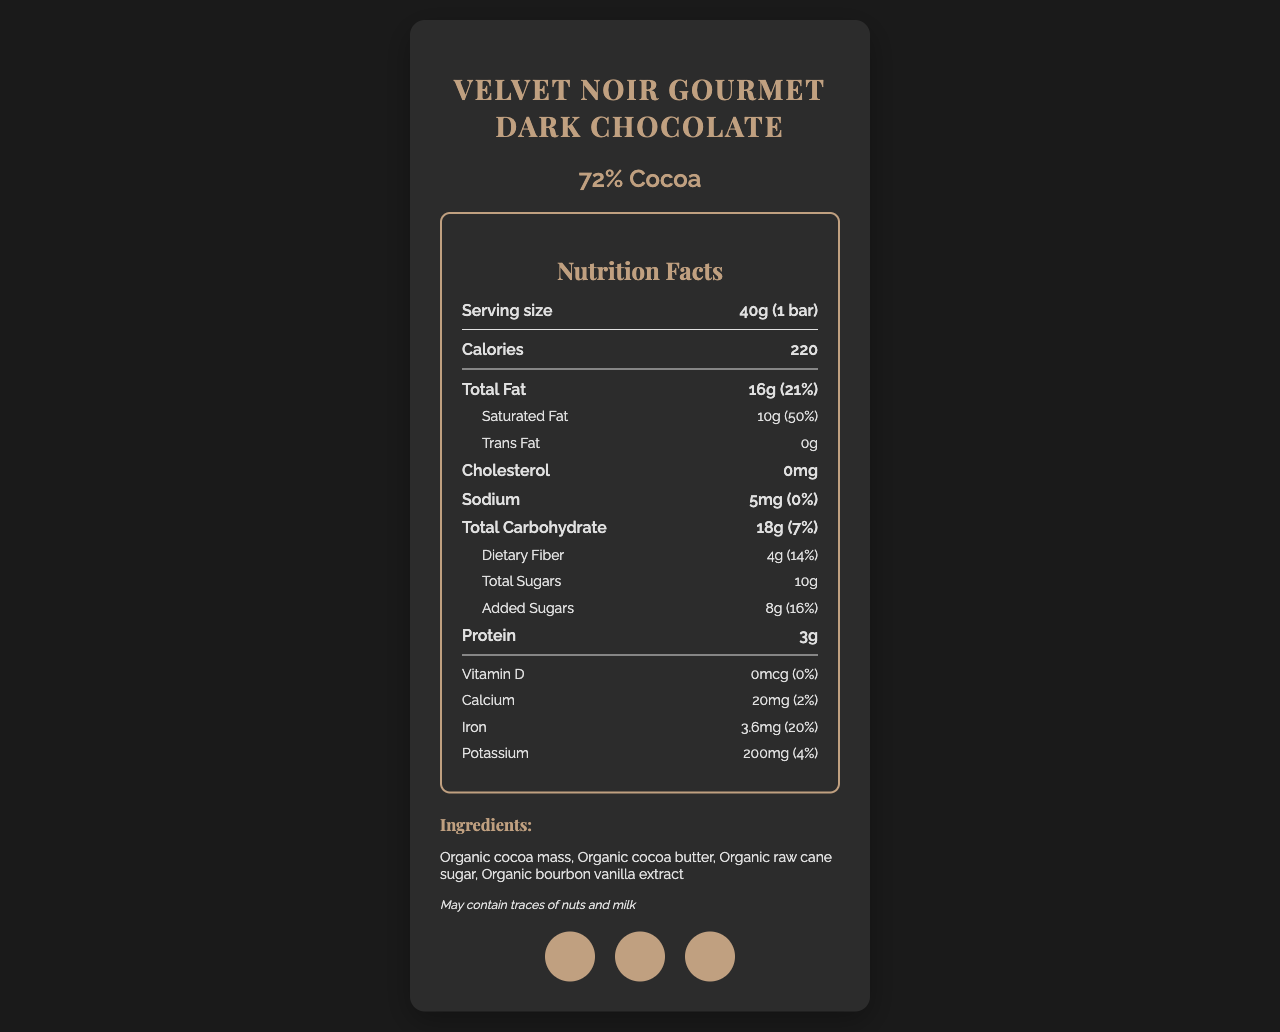how many calories are in a serving of Velvet Noir Gourmet Dark Chocolate? The document explicitly states that there are 220 calories per serving.
Answer: 220 what is the serving size for this dark chocolate bar? The serving size is clearly mentioned as "40g (1 bar)".
Answer: 40g (1 bar) how much total fat does one serving contain? The nutrition facts section lists the total fat content as 16g per serving.
Answer: 16g what percentage of the daily value of saturated fat is in one serving? The document states that one serving contains 10g of saturated fat, which is 50% of the daily value.
Answer: 50% are there any added sugars in this chocolate bar? The nutrition facts state that there are 8g of added sugars, which is 16% of the daily value.
Answer: Yes how many grams of dietary fiber does one serving provide? The document mentions that one serving contains 4g of dietary fiber.
Answer: 4g what is the iron content expressed as a percentage of daily value? One serving provides 3.6mg of iron, which corresponds to 20% of the daily value.
Answer: 20% what is the primary color palette used in the design of the packaging? A. Yellow and Blue B. Black and Gold C. Red and White The background color is #1A1A1A (black), the text color is #E0E0E0 (grey), and the accent color is #C0A080 (gold).
Answer: B which of the following certifications does this chocolate bar have? A. USDA Organic B. Rainforest Alliance Certified C. Gluten-Free The document lists USDA Organic, Fair Trade Certified, and Non-GMO Project Verified as certification logos.
Answer: A what font is used for the text on this label? The design elements section of the document specifies that Helvetica Neue is the font used.
Answer: Helvetica Neue is there any cholesterol in this chocolate bar? The nutrition facts state that there is 0mg of cholesterol in one serving.
Answer: No does this chocolate bar contain any milk or nuts? The allergen information section indicates that the product may contain traces of nuts and milk.
Answer: May contain traces of nuts and milk summarize the main design elements and nutrition facts of the Velvet Noir Gourmet Dark Chocolate bar. The summary includes the main points about the design elements (matte finish, gold accents, geometric patterns) and the key nutrition facts (calories, fats, fiber, sugars), as well as the brand values and certifications.
Answer: Velvet Noir Gourmet Dark Chocolate bar features a sleek design with a soft-touch matte finish, gold foil accents, and minimalist geometric patterns. The nutrition facts highlight that a 40g serving contains 220 calories, 16g of total fat, 10g of saturated fat, 4g of dietary fiber, and 10g of total sugars, with 8g of added sugars. The product is ethically sourced, uses sustainable packaging, and is certified as USDA Organic, Fair Trade Certified, and Non-GMO Project Verified. what is the cost of this chocolate bar? The document does not provide any information about the price of the chocolate bar.
Answer: Not enough information 